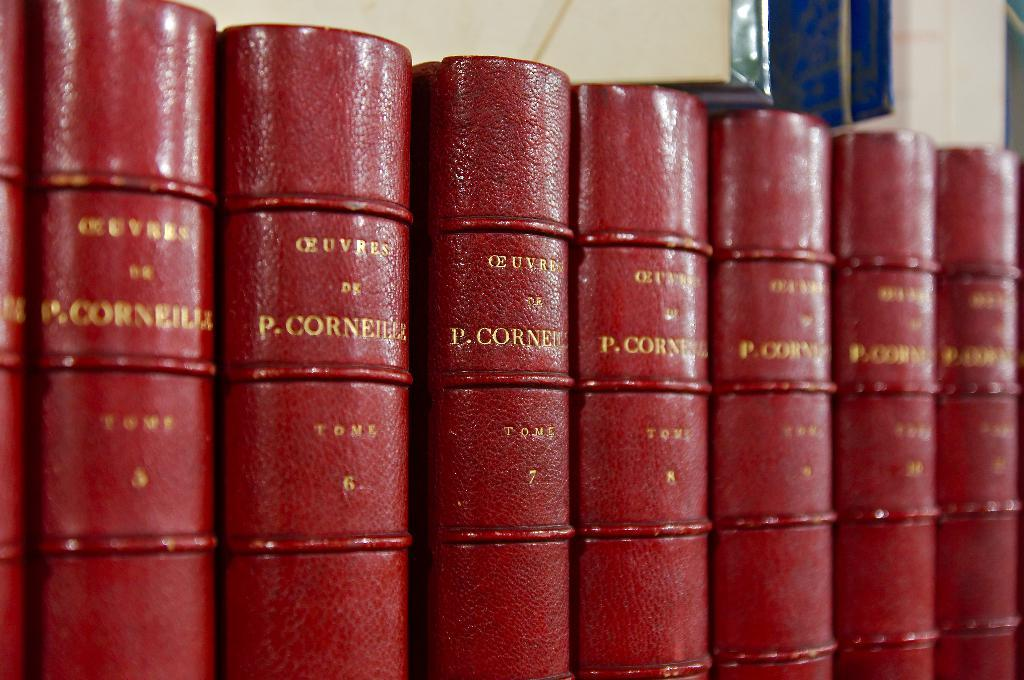<image>
Share a concise interpretation of the image provided. A row of books by P. Corneilla stand side by side. 